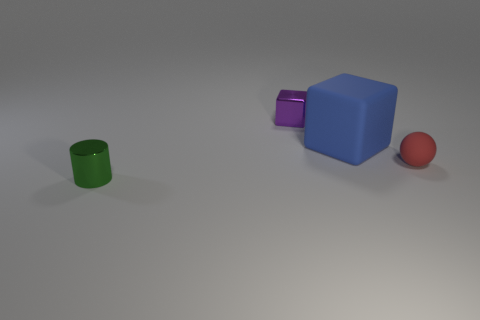Subtract all purple cubes. How many cubes are left? 1 Subtract all cylinders. How many objects are left? 3 Subtract 1 cylinders. How many cylinders are left? 0 Subtract all red cubes. Subtract all gray spheres. How many cubes are left? 2 Subtract all green spheres. How many red cylinders are left? 0 Subtract all large green matte objects. Subtract all tiny rubber things. How many objects are left? 3 Add 2 objects. How many objects are left? 6 Add 2 yellow balls. How many yellow balls exist? 2 Add 4 tiny green metal things. How many objects exist? 8 Subtract 1 green cylinders. How many objects are left? 3 